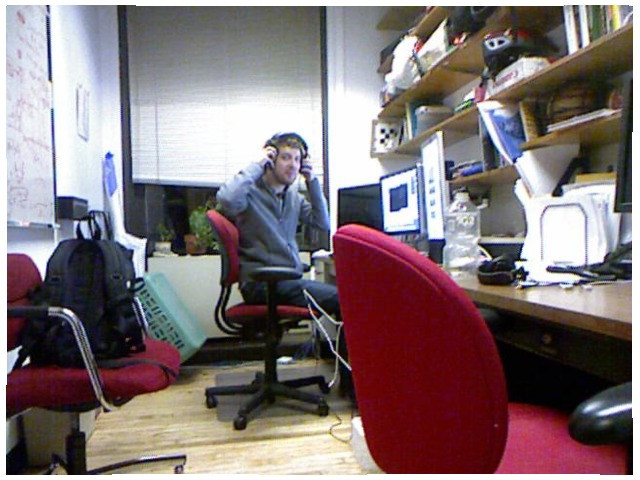<image>
Is the headphones above the man? No. The headphones is not positioned above the man. The vertical arrangement shows a different relationship. Is there a man on the chair? Yes. Looking at the image, I can see the man is positioned on top of the chair, with the chair providing support. Is there a backpack on the chair? Yes. Looking at the image, I can see the backpack is positioned on top of the chair, with the chair providing support. Where is the man in relation to the chair? Is it on the chair? No. The man is not positioned on the chair. They may be near each other, but the man is not supported by or resting on top of the chair. Is the chair on the table? No. The chair is not positioned on the table. They may be near each other, but the chair is not supported by or resting on top of the table. Is the chair to the left of the chair? No. The chair is not to the left of the chair. From this viewpoint, they have a different horizontal relationship. Is there a man under the headphones? Yes. The man is positioned underneath the headphones, with the headphones above it in the vertical space. Is there a man under the chair? No. The man is not positioned under the chair. The vertical relationship between these objects is different. 